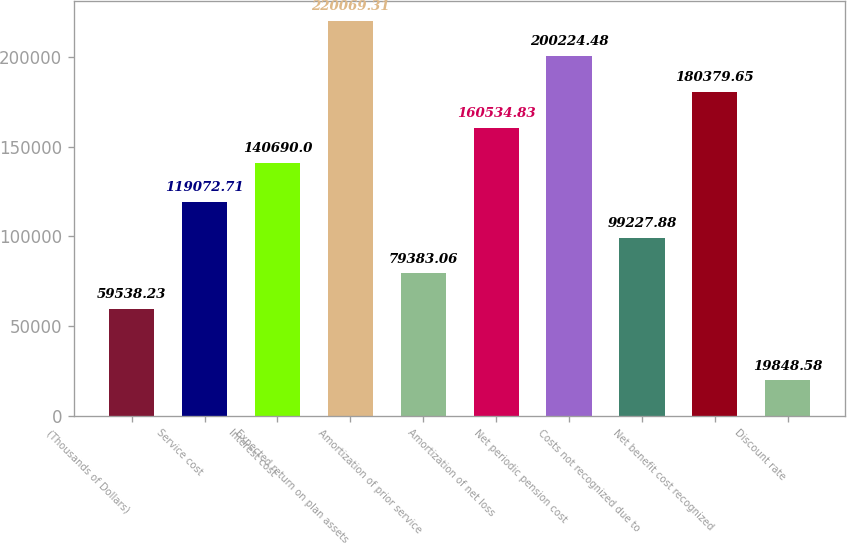<chart> <loc_0><loc_0><loc_500><loc_500><bar_chart><fcel>(Thousands of Dollars)<fcel>Service cost<fcel>Interest cost<fcel>Expected return on plan assets<fcel>Amortization of prior service<fcel>Amortization of net loss<fcel>Net periodic pension cost<fcel>Costs not recognized due to<fcel>Net benefit cost recognized<fcel>Discount rate<nl><fcel>59538.2<fcel>119073<fcel>140690<fcel>220069<fcel>79383.1<fcel>160535<fcel>200224<fcel>99227.9<fcel>180380<fcel>19848.6<nl></chart> 